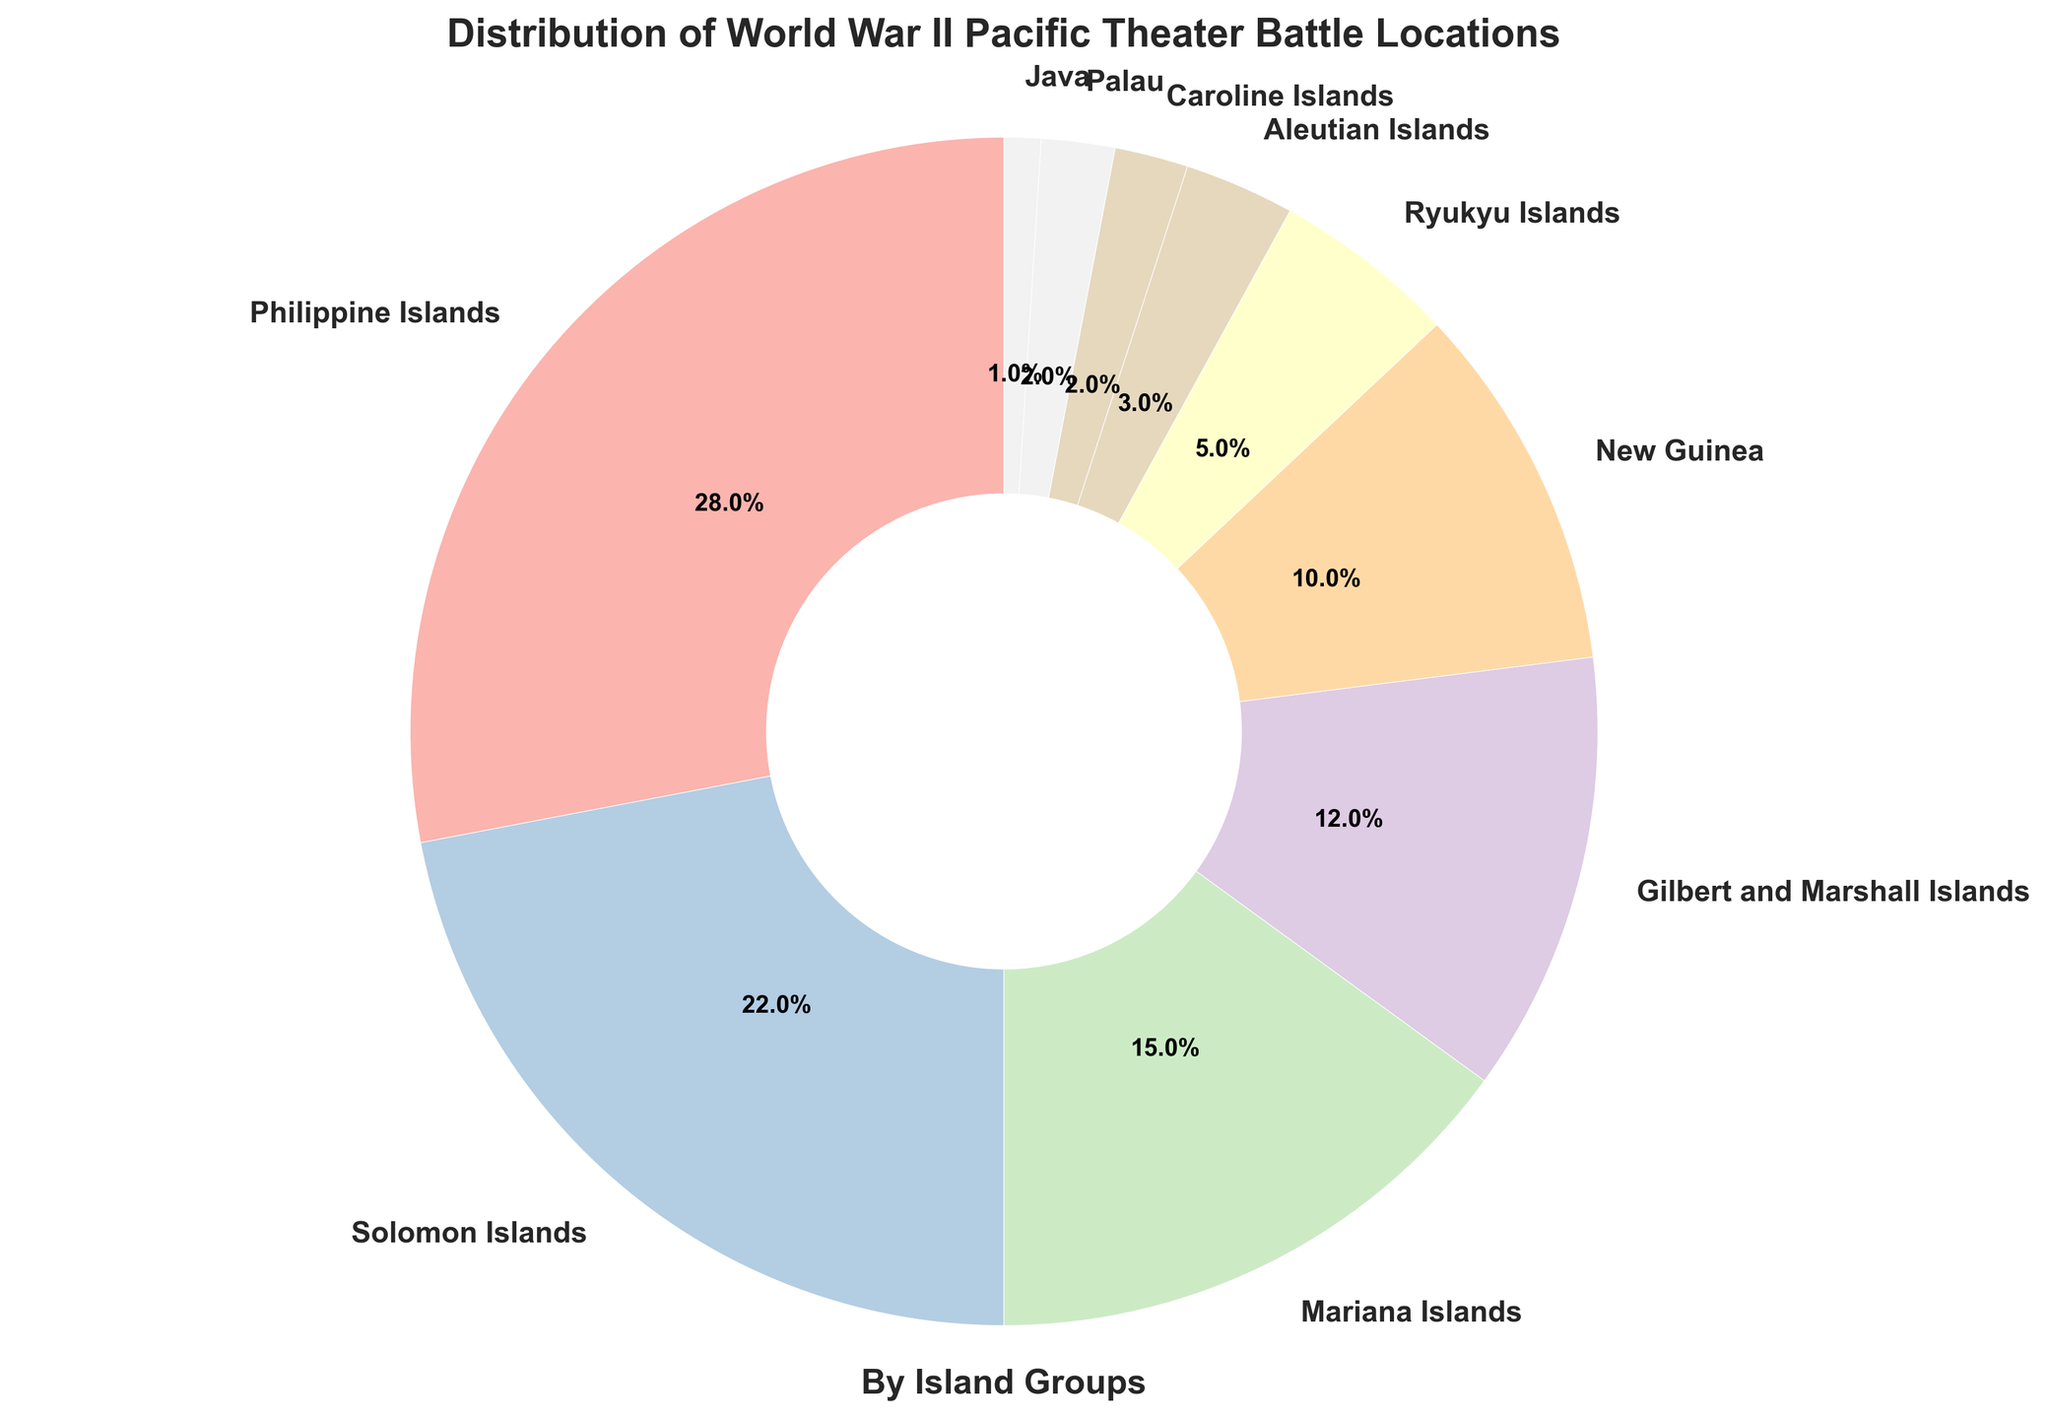Which island group has the highest percentage of World War II Pacific Theater battle locations? The largest wedge, representing 28%, is labeled as the Philippine Islands.
Answer: Philippine Islands Which three island groups together account for the majority of battle locations? Adding up the percentages of the Philippine Islands (28%), Solomon Islands (22%), and Mariana Islands (15%) gives 65%, which is more than half.
Answer: Philippine Islands, Solomon Islands, Mariana Islands How much greater is the percentage of battle locations in the Solomon Islands compared to the Gilbert and Marshall Islands? Subtracting the percentage of the Gilbert and Marshall Islands (12%) from the Solomon Islands (22%) gives 10%.
Answer: 10% Which island groups have the smallest percentages of battle locations, each with 2% or less? The smallest wedges with 2% or less are labeled Caroline Islands, Palau, and Java (2%, 2%, and 1%, respectively).
Answer: Caroline Islands, Palau, Java What percentage of battle locations occurred in the Aleutian Islands? The wedge labeled Aleutian Islands shows 3%.
Answer: 3% Combine the percentages of the Aleutian Islands, Caroline Islands, Palau, and Java. What is the total percentage? Adding the percentages of the Aleutian Islands (3%), Caroline Islands (2%), Palau (2%), and Java (1%) gives 8%.
Answer: 8% How does the percentage of battle locations in the Ryukyu Islands compare to New Guinea? The Ryukyu Islands have 5%, whereas New Guinea has 10%, so New Guinea has 5% more.
Answer: New Guinea has 5% more Create a new island group by combining the Mariana Islands and New Guinea. What percentage does this new group represent? Adding the percentages of the Mariana Islands (15%) and New Guinea (10%) gives 25%.
Answer: 25% Identify the island group with the largest wedge that is not part of the top three island groups by percentage. The top three island groups are the Philippine Islands (28%), Solomon Islands (22%), and Mariana Islands (15%). The next largest is Gilbert and Marshall Islands with 12%.
Answer: Gilbert and Marshall Islands If the Philippine Islands and Solomon Islands were combined into one group, what fraction of the pie chart would they occupy? Adding the percentages of the Philippine Islands (28%) and Solomon Islands (22%) gives 50%, which is half of the pie chart.
Answer: 50% 